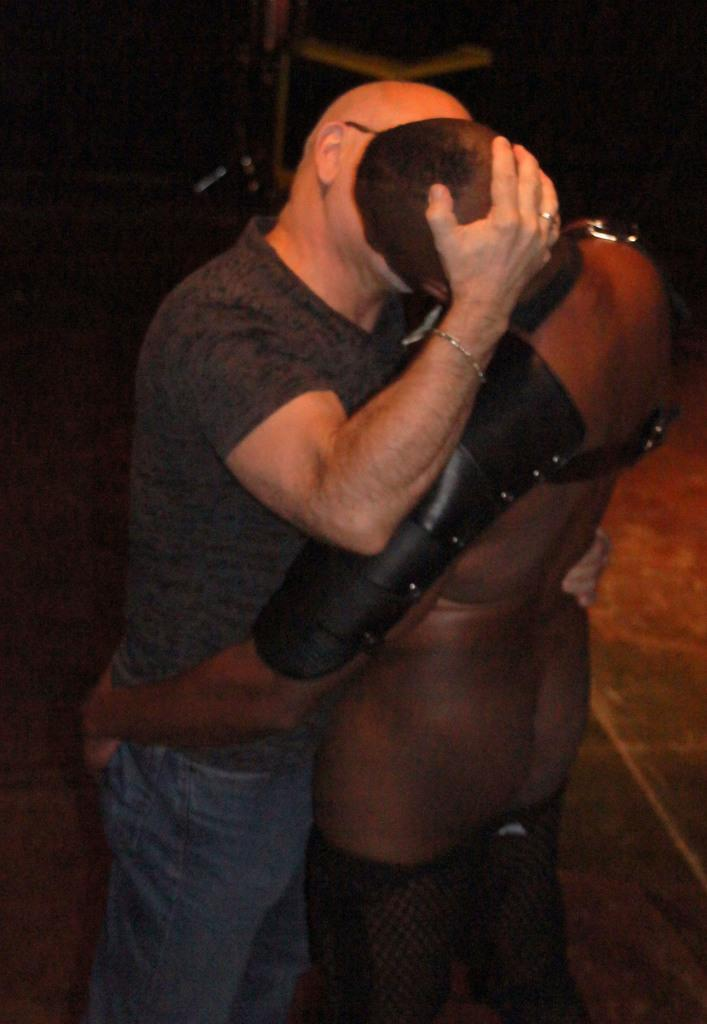How many people are in the image? There are two people in the image. What are the two people doing in the image? The two people are kissing. What type of leaf can be seen falling from the tree in the image? There is no tree or leaf present in the image; it only features two people kissing. What flavor of mint is being used in the image? There is no mint present in the image. 